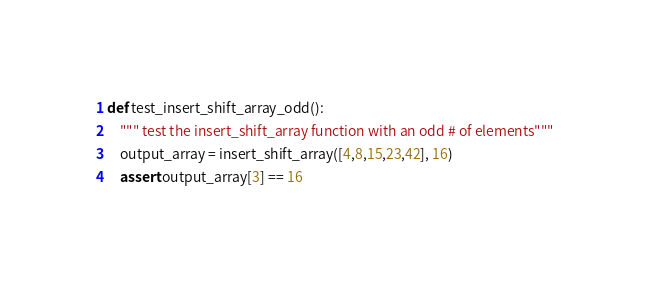Convert code to text. <code><loc_0><loc_0><loc_500><loc_500><_Python_>def test_insert_shift_array_odd():
    """ test the insert_shift_array function with an odd # of elements"""
    output_array = insert_shift_array([4,8,15,23,42], 16)
    assert output_array[3] == 16
</code> 